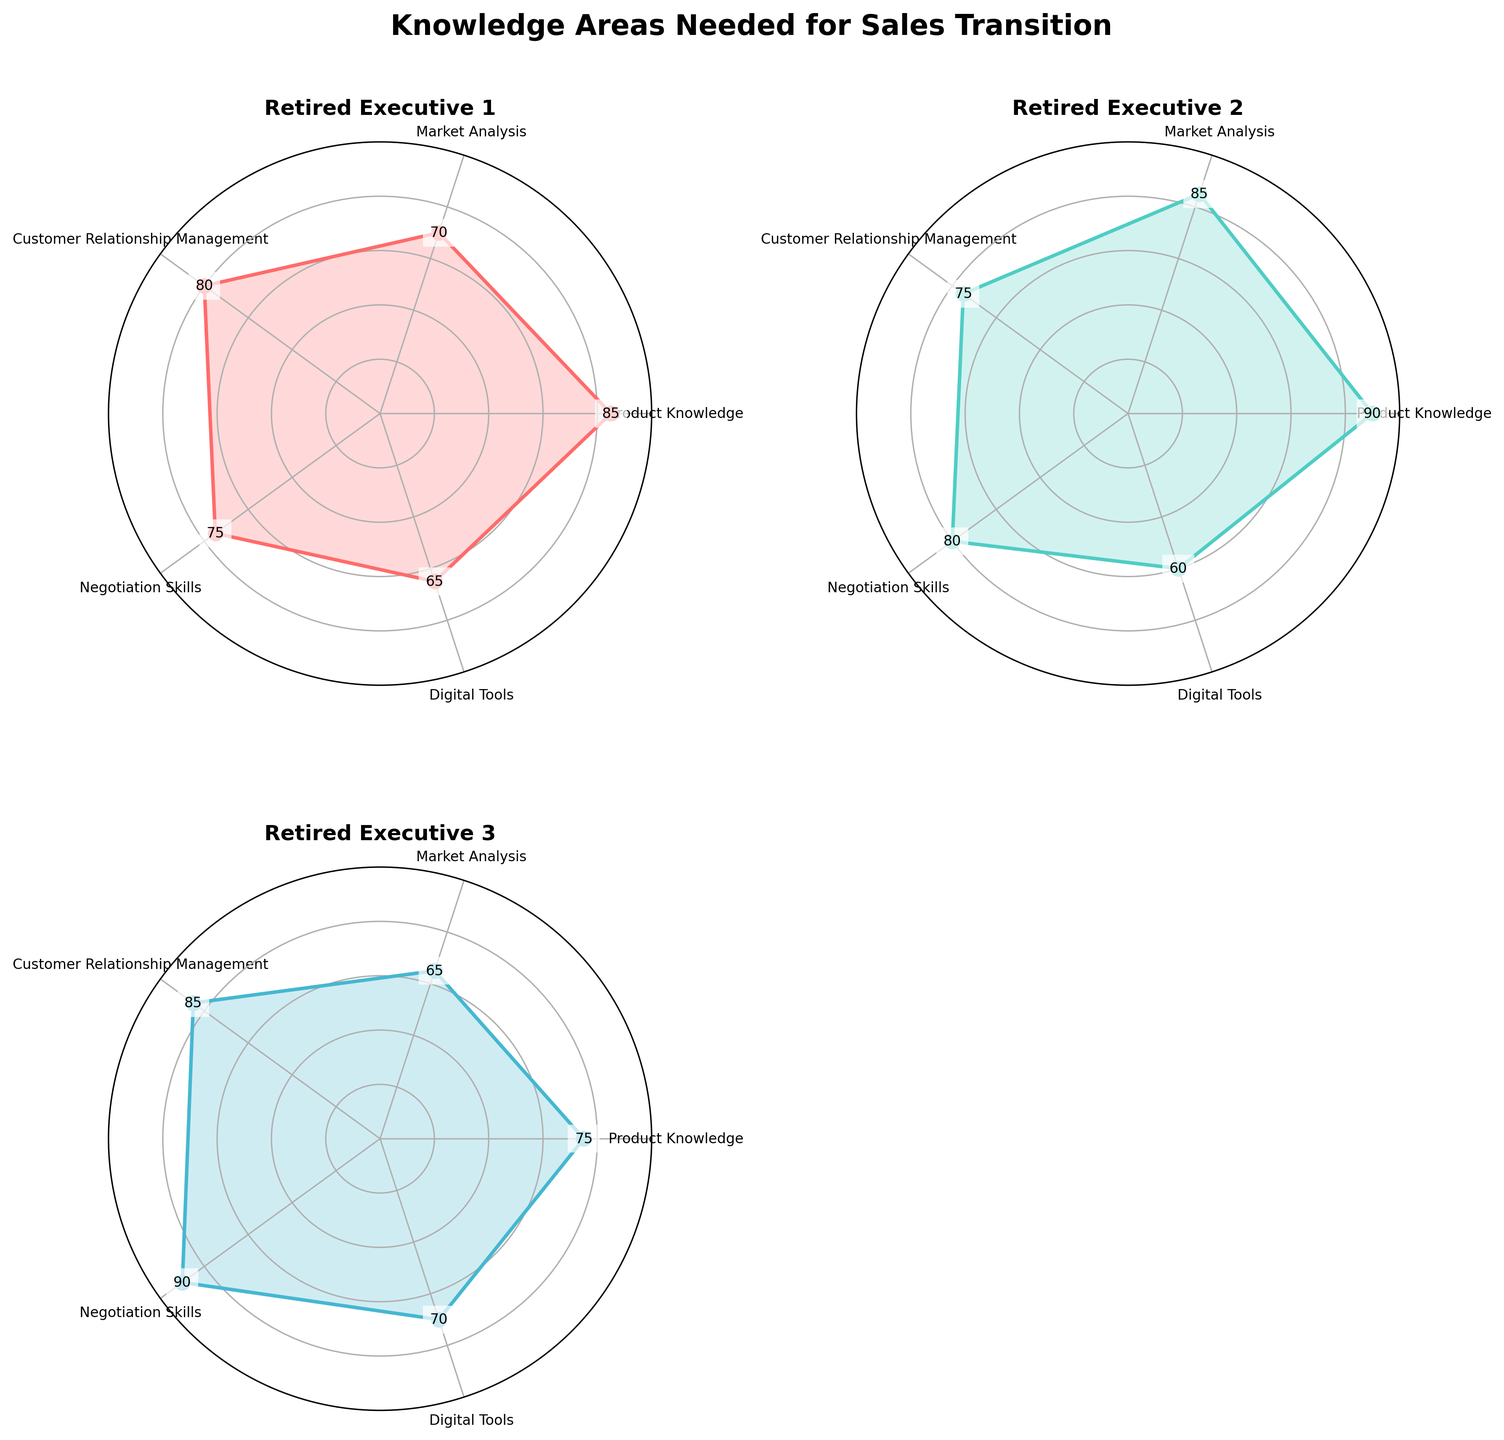How many knowledge areas are assessed for each retired executive? There are 5 knowledge areas listed: Product Knowledge, Market Analysis, Customer Relationship Management, Negotiation Skills, and Digital Tools.
Answer: 5 What is the title of the radar chart figure? The title is explicitly stated at the top of the figure.
Answer: Knowledge Areas Needed for Sales Transition Which executive has the highest score in Market Analysis? By comparing the Market Analysis scores for all the executives, Retired Executive 4 has the highest score of 90.
Answer: Retired Executive 4 Which knowledge area has the lowest score for Retired Executive 1? For Retired Executive 1, Digital Tools has the lowest score among all areas with a value of 65.
Answer: Digital Tools What’s the difference in Product Knowledge scores between the highest and the lowest scoring executives? Retired Executive 2 has the highest score in Product Knowledge with 90, while Retired Executive 3 has the lowest with 75. The difference is 90 - 75 = 15.
Answer: 15 Which knowledge area has the most consistent scores among the executives? By examining the knowledge areas, Customer Relationship Management shows relatively consistent scores: 80, 75, 85, and 95.
Answer: Customer Relationship Management How many subplots are there in the figure? There are a total of 4 subplots, one for each retired executive.
Answer: 4 Which executive has the broadest range (maximum difference) in their knowledge area scores? By calculating the range (max score - min score) for each executive: 
Retired Executive 1: 85-65=20 
Retired Executive 2: 90-60=30 
Retired Executive 3: 90-65=25 
Retired Executive 4: 95-70=25 
Retired Executive 2 has the highest range of 30.
Answer: Retired Executive 2 